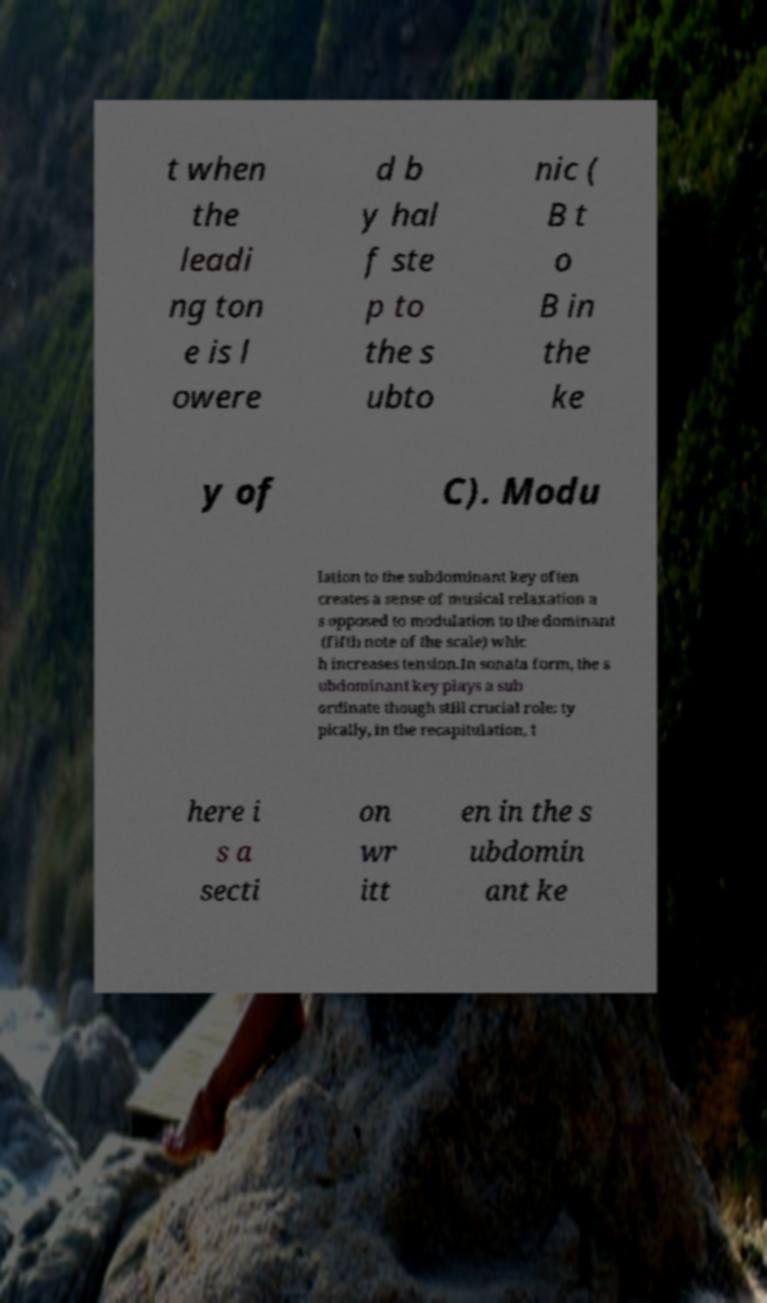Could you assist in decoding the text presented in this image and type it out clearly? t when the leadi ng ton e is l owere d b y hal f ste p to the s ubto nic ( B t o B in the ke y of C). Modu lation to the subdominant key often creates a sense of musical relaxation a s opposed to modulation to the dominant (fifth note of the scale) whic h increases tension.In sonata form, the s ubdominant key plays a sub ordinate though still crucial role: ty pically, in the recapitulation, t here i s a secti on wr itt en in the s ubdomin ant ke 